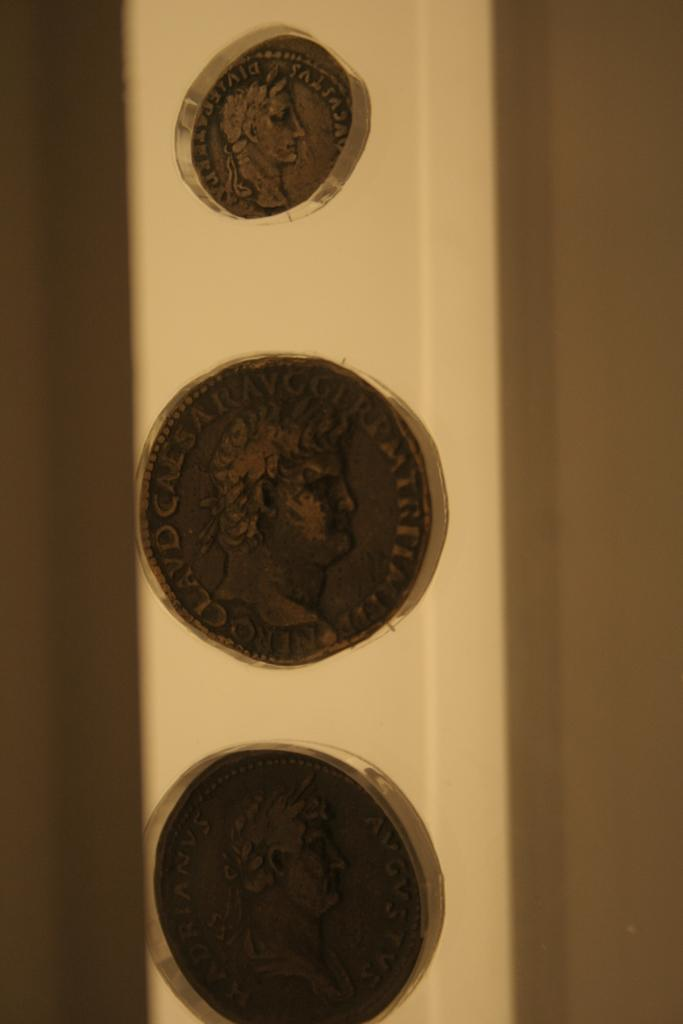How many coins are visible in the image? There are three coins in the image. What is written or depicted on the coins? There is text on the coins. Can you describe the person in the image? There is a man in the image. What can be seen in the background of the image? There is a wall in the background of the image. What type of salt is the man using to season the bear in the image? There is no salt, bear, or any indication of seasoning in the image. 